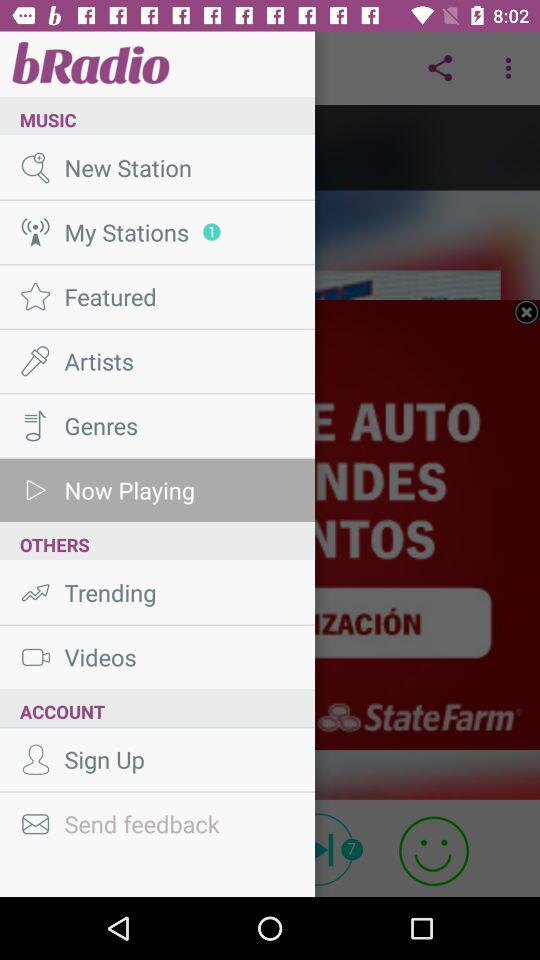What is the name of the application? The name of the application is "bRadio". 